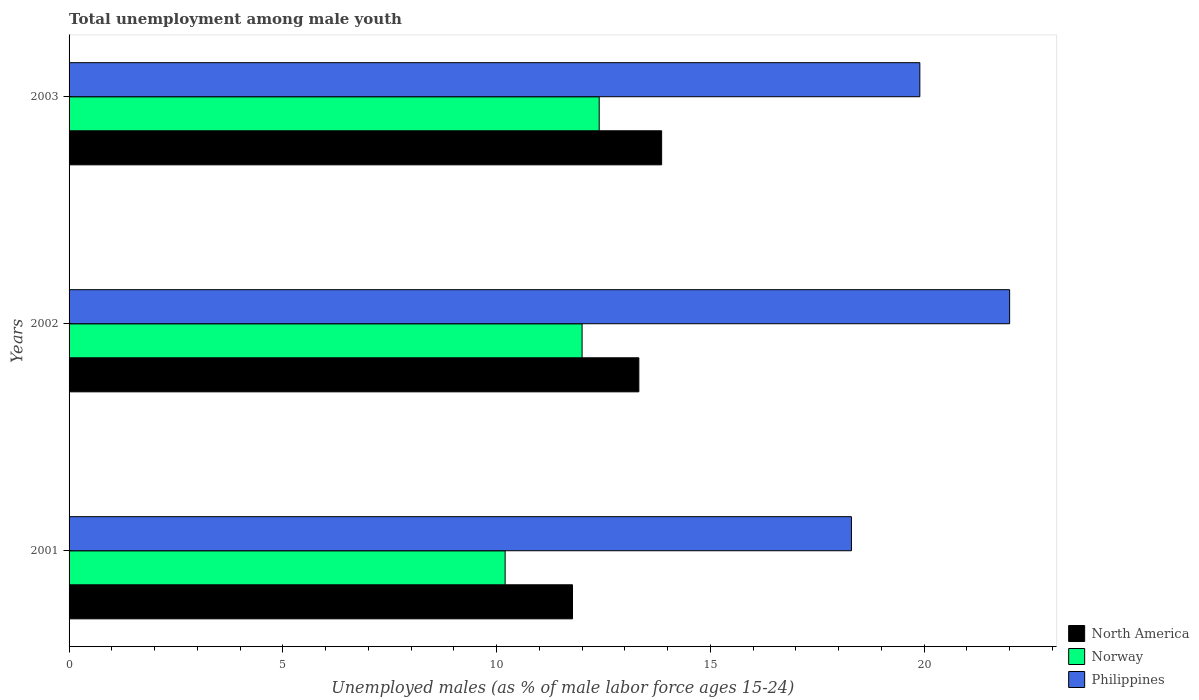How many different coloured bars are there?
Make the answer very short. 3. Are the number of bars per tick equal to the number of legend labels?
Keep it short and to the point. Yes. Are the number of bars on each tick of the Y-axis equal?
Ensure brevity in your answer.  Yes. How many bars are there on the 1st tick from the bottom?
Ensure brevity in your answer.  3. In how many cases, is the number of bars for a given year not equal to the number of legend labels?
Give a very brief answer. 0. What is the percentage of unemployed males in in Norway in 2003?
Keep it short and to the point. 12.4. Across all years, what is the minimum percentage of unemployed males in in Philippines?
Keep it short and to the point. 18.3. What is the total percentage of unemployed males in in Norway in the graph?
Make the answer very short. 34.6. What is the difference between the percentage of unemployed males in in Norway in 2001 and that in 2003?
Your answer should be very brief. -2.2. What is the difference between the percentage of unemployed males in in Norway in 2003 and the percentage of unemployed males in in North America in 2002?
Give a very brief answer. -0.93. What is the average percentage of unemployed males in in Norway per year?
Offer a very short reply. 11.53. In how many years, is the percentage of unemployed males in in Philippines greater than 4 %?
Keep it short and to the point. 3. What is the ratio of the percentage of unemployed males in in Philippines in 2001 to that in 2002?
Keep it short and to the point. 0.83. Is the difference between the percentage of unemployed males in in Philippines in 2001 and 2003 greater than the difference between the percentage of unemployed males in in Norway in 2001 and 2003?
Provide a succinct answer. Yes. What is the difference between the highest and the second highest percentage of unemployed males in in Philippines?
Offer a very short reply. 2.1. What is the difference between the highest and the lowest percentage of unemployed males in in Philippines?
Keep it short and to the point. 3.7. What does the 2nd bar from the top in 2001 represents?
Offer a very short reply. Norway. How many bars are there?
Your answer should be very brief. 9. Are all the bars in the graph horizontal?
Provide a short and direct response. Yes. Are the values on the major ticks of X-axis written in scientific E-notation?
Give a very brief answer. No. Does the graph contain any zero values?
Your answer should be compact. No. Does the graph contain grids?
Ensure brevity in your answer.  No. What is the title of the graph?
Make the answer very short. Total unemployment among male youth. What is the label or title of the X-axis?
Give a very brief answer. Unemployed males (as % of male labor force ages 15-24). What is the label or title of the Y-axis?
Your answer should be compact. Years. What is the Unemployed males (as % of male labor force ages 15-24) of North America in 2001?
Keep it short and to the point. 11.78. What is the Unemployed males (as % of male labor force ages 15-24) in Norway in 2001?
Offer a terse response. 10.2. What is the Unemployed males (as % of male labor force ages 15-24) in Philippines in 2001?
Provide a short and direct response. 18.3. What is the Unemployed males (as % of male labor force ages 15-24) of North America in 2002?
Make the answer very short. 13.33. What is the Unemployed males (as % of male labor force ages 15-24) of North America in 2003?
Offer a very short reply. 13.86. What is the Unemployed males (as % of male labor force ages 15-24) in Norway in 2003?
Offer a very short reply. 12.4. What is the Unemployed males (as % of male labor force ages 15-24) in Philippines in 2003?
Ensure brevity in your answer.  19.9. Across all years, what is the maximum Unemployed males (as % of male labor force ages 15-24) of North America?
Provide a short and direct response. 13.86. Across all years, what is the maximum Unemployed males (as % of male labor force ages 15-24) of Norway?
Ensure brevity in your answer.  12.4. Across all years, what is the maximum Unemployed males (as % of male labor force ages 15-24) in Philippines?
Give a very brief answer. 22. Across all years, what is the minimum Unemployed males (as % of male labor force ages 15-24) of North America?
Ensure brevity in your answer.  11.78. Across all years, what is the minimum Unemployed males (as % of male labor force ages 15-24) in Norway?
Give a very brief answer. 10.2. Across all years, what is the minimum Unemployed males (as % of male labor force ages 15-24) of Philippines?
Your answer should be very brief. 18.3. What is the total Unemployed males (as % of male labor force ages 15-24) in North America in the graph?
Give a very brief answer. 38.96. What is the total Unemployed males (as % of male labor force ages 15-24) of Norway in the graph?
Offer a very short reply. 34.6. What is the total Unemployed males (as % of male labor force ages 15-24) in Philippines in the graph?
Offer a terse response. 60.2. What is the difference between the Unemployed males (as % of male labor force ages 15-24) in North America in 2001 and that in 2002?
Give a very brief answer. -1.55. What is the difference between the Unemployed males (as % of male labor force ages 15-24) of Norway in 2001 and that in 2002?
Your answer should be very brief. -1.8. What is the difference between the Unemployed males (as % of male labor force ages 15-24) in North America in 2001 and that in 2003?
Offer a terse response. -2.08. What is the difference between the Unemployed males (as % of male labor force ages 15-24) in North America in 2002 and that in 2003?
Make the answer very short. -0.53. What is the difference between the Unemployed males (as % of male labor force ages 15-24) in Norway in 2002 and that in 2003?
Make the answer very short. -0.4. What is the difference between the Unemployed males (as % of male labor force ages 15-24) in Philippines in 2002 and that in 2003?
Your answer should be very brief. 2.1. What is the difference between the Unemployed males (as % of male labor force ages 15-24) in North America in 2001 and the Unemployed males (as % of male labor force ages 15-24) in Norway in 2002?
Keep it short and to the point. -0.22. What is the difference between the Unemployed males (as % of male labor force ages 15-24) of North America in 2001 and the Unemployed males (as % of male labor force ages 15-24) of Philippines in 2002?
Ensure brevity in your answer.  -10.22. What is the difference between the Unemployed males (as % of male labor force ages 15-24) of North America in 2001 and the Unemployed males (as % of male labor force ages 15-24) of Norway in 2003?
Give a very brief answer. -0.62. What is the difference between the Unemployed males (as % of male labor force ages 15-24) in North America in 2001 and the Unemployed males (as % of male labor force ages 15-24) in Philippines in 2003?
Provide a short and direct response. -8.12. What is the difference between the Unemployed males (as % of male labor force ages 15-24) in North America in 2002 and the Unemployed males (as % of male labor force ages 15-24) in Norway in 2003?
Provide a succinct answer. 0.93. What is the difference between the Unemployed males (as % of male labor force ages 15-24) of North America in 2002 and the Unemployed males (as % of male labor force ages 15-24) of Philippines in 2003?
Your answer should be very brief. -6.57. What is the average Unemployed males (as % of male labor force ages 15-24) of North America per year?
Provide a succinct answer. 12.99. What is the average Unemployed males (as % of male labor force ages 15-24) in Norway per year?
Offer a very short reply. 11.53. What is the average Unemployed males (as % of male labor force ages 15-24) in Philippines per year?
Give a very brief answer. 20.07. In the year 2001, what is the difference between the Unemployed males (as % of male labor force ages 15-24) of North America and Unemployed males (as % of male labor force ages 15-24) of Norway?
Your answer should be very brief. 1.58. In the year 2001, what is the difference between the Unemployed males (as % of male labor force ages 15-24) in North America and Unemployed males (as % of male labor force ages 15-24) in Philippines?
Give a very brief answer. -6.52. In the year 2002, what is the difference between the Unemployed males (as % of male labor force ages 15-24) in North America and Unemployed males (as % of male labor force ages 15-24) in Norway?
Provide a succinct answer. 1.33. In the year 2002, what is the difference between the Unemployed males (as % of male labor force ages 15-24) in North America and Unemployed males (as % of male labor force ages 15-24) in Philippines?
Ensure brevity in your answer.  -8.67. In the year 2003, what is the difference between the Unemployed males (as % of male labor force ages 15-24) of North America and Unemployed males (as % of male labor force ages 15-24) of Norway?
Offer a very short reply. 1.46. In the year 2003, what is the difference between the Unemployed males (as % of male labor force ages 15-24) in North America and Unemployed males (as % of male labor force ages 15-24) in Philippines?
Offer a terse response. -6.04. In the year 2003, what is the difference between the Unemployed males (as % of male labor force ages 15-24) of Norway and Unemployed males (as % of male labor force ages 15-24) of Philippines?
Give a very brief answer. -7.5. What is the ratio of the Unemployed males (as % of male labor force ages 15-24) of North America in 2001 to that in 2002?
Make the answer very short. 0.88. What is the ratio of the Unemployed males (as % of male labor force ages 15-24) in Philippines in 2001 to that in 2002?
Keep it short and to the point. 0.83. What is the ratio of the Unemployed males (as % of male labor force ages 15-24) in North America in 2001 to that in 2003?
Provide a succinct answer. 0.85. What is the ratio of the Unemployed males (as % of male labor force ages 15-24) of Norway in 2001 to that in 2003?
Your response must be concise. 0.82. What is the ratio of the Unemployed males (as % of male labor force ages 15-24) in Philippines in 2001 to that in 2003?
Provide a succinct answer. 0.92. What is the ratio of the Unemployed males (as % of male labor force ages 15-24) of North America in 2002 to that in 2003?
Give a very brief answer. 0.96. What is the ratio of the Unemployed males (as % of male labor force ages 15-24) of Philippines in 2002 to that in 2003?
Offer a terse response. 1.11. What is the difference between the highest and the second highest Unemployed males (as % of male labor force ages 15-24) in North America?
Make the answer very short. 0.53. What is the difference between the highest and the lowest Unemployed males (as % of male labor force ages 15-24) in North America?
Keep it short and to the point. 2.08. What is the difference between the highest and the lowest Unemployed males (as % of male labor force ages 15-24) of Philippines?
Your response must be concise. 3.7. 